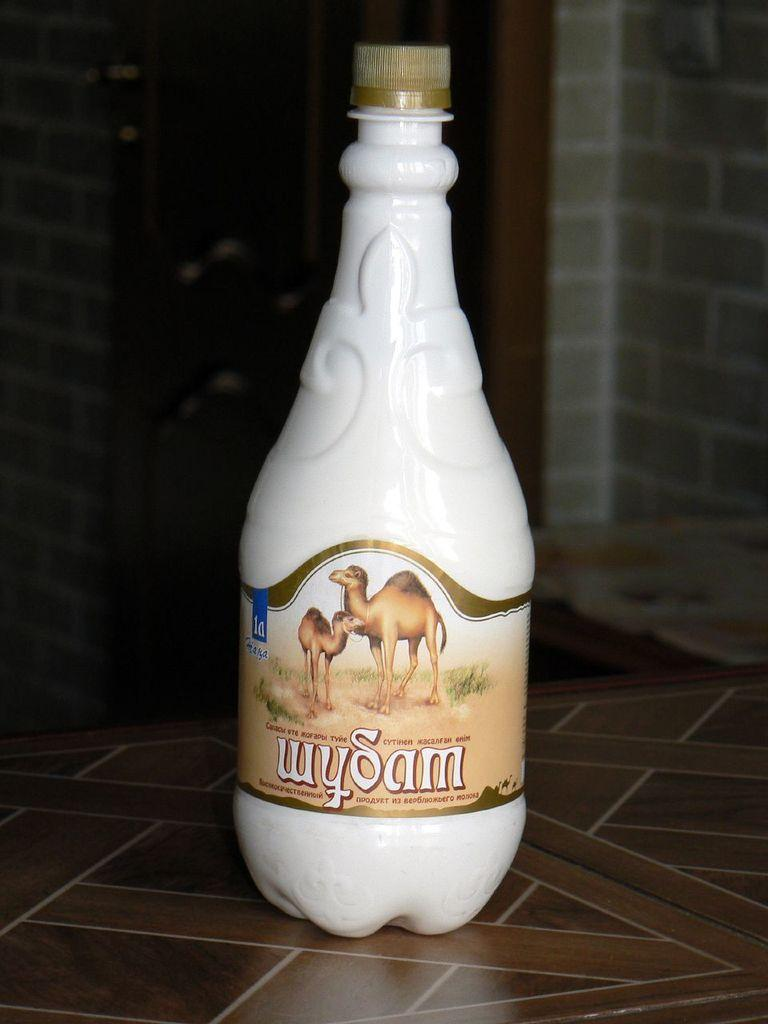<image>
Describe the image concisely. White bottle with gold lid wySam with camels on the label 